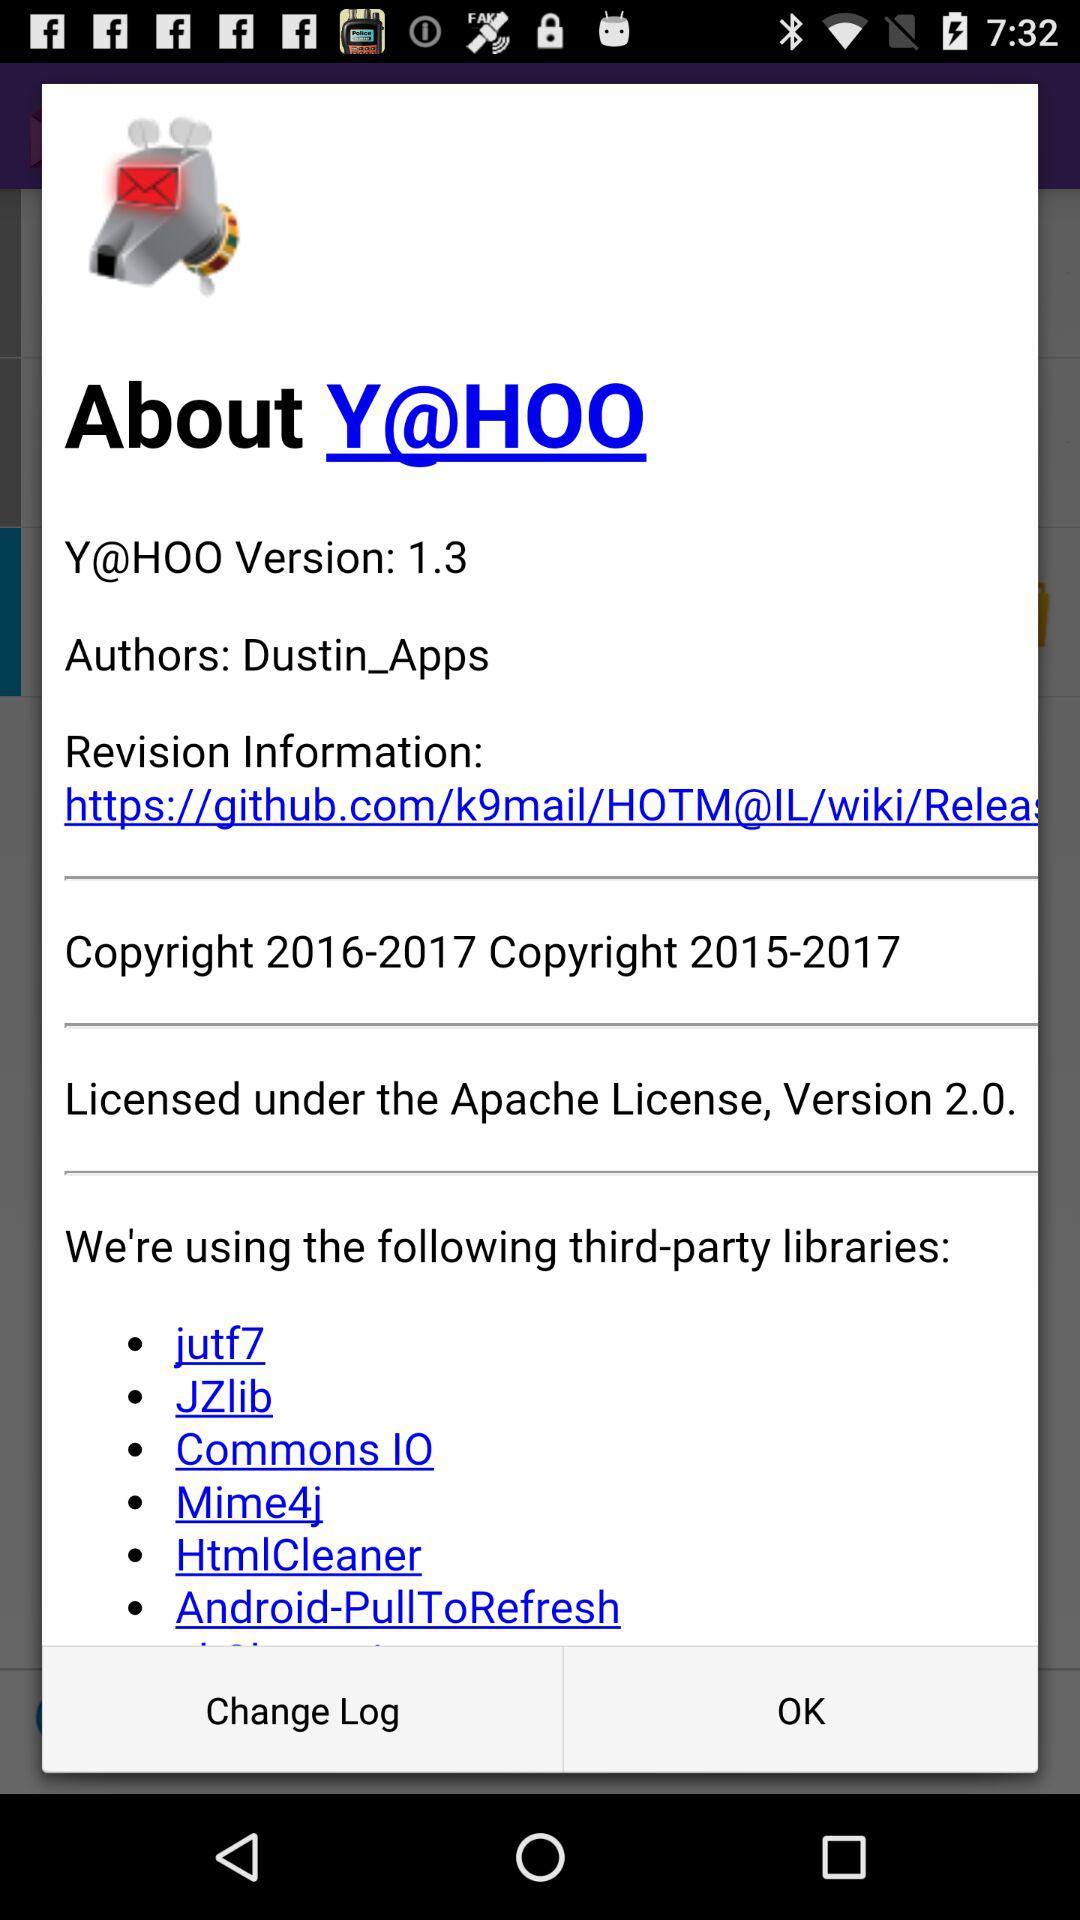How many third-party libraries are used? 6 